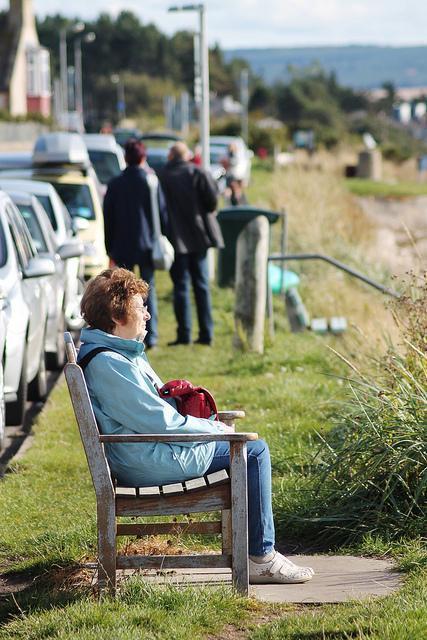How are her shoes tightened?
Select the accurate answer and provide justification: `Answer: choice
Rationale: srationale.`
Options: Velcro, buckles, zippers, laces. Answer: velcro.
Rationale: They don't have the other options. 